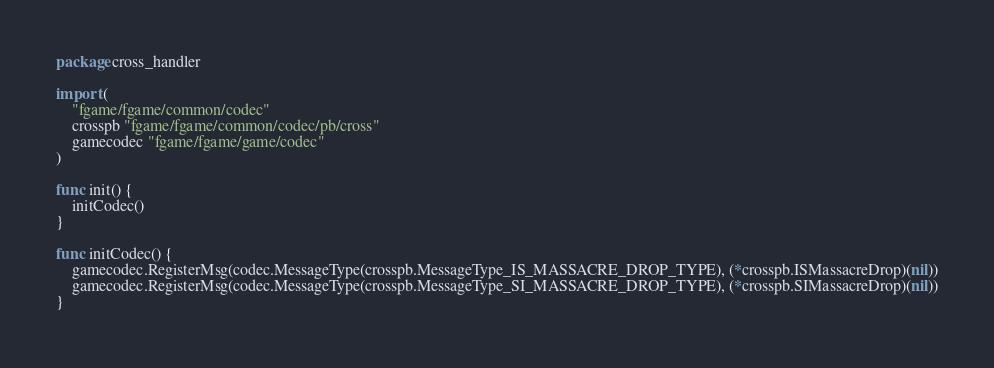<code> <loc_0><loc_0><loc_500><loc_500><_Go_>package cross_handler

import (
	"fgame/fgame/common/codec"
	crosspb "fgame/fgame/common/codec/pb/cross"
	gamecodec "fgame/fgame/game/codec"
)

func init() {
	initCodec()
}

func initCodec() {
	gamecodec.RegisterMsg(codec.MessageType(crosspb.MessageType_IS_MASSACRE_DROP_TYPE), (*crosspb.ISMassacreDrop)(nil))
	gamecodec.RegisterMsg(codec.MessageType(crosspb.MessageType_SI_MASSACRE_DROP_TYPE), (*crosspb.SIMassacreDrop)(nil))
}
</code> 